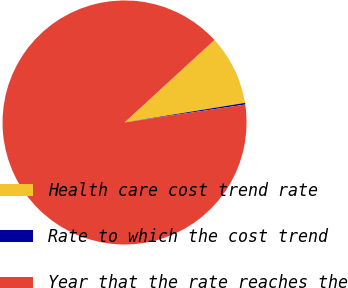Convert chart to OTSL. <chart><loc_0><loc_0><loc_500><loc_500><pie_chart><fcel>Health care cost trend rate<fcel>Rate to which the cost trend<fcel>Year that the rate reaches the<nl><fcel>9.25%<fcel>0.22%<fcel>90.52%<nl></chart> 